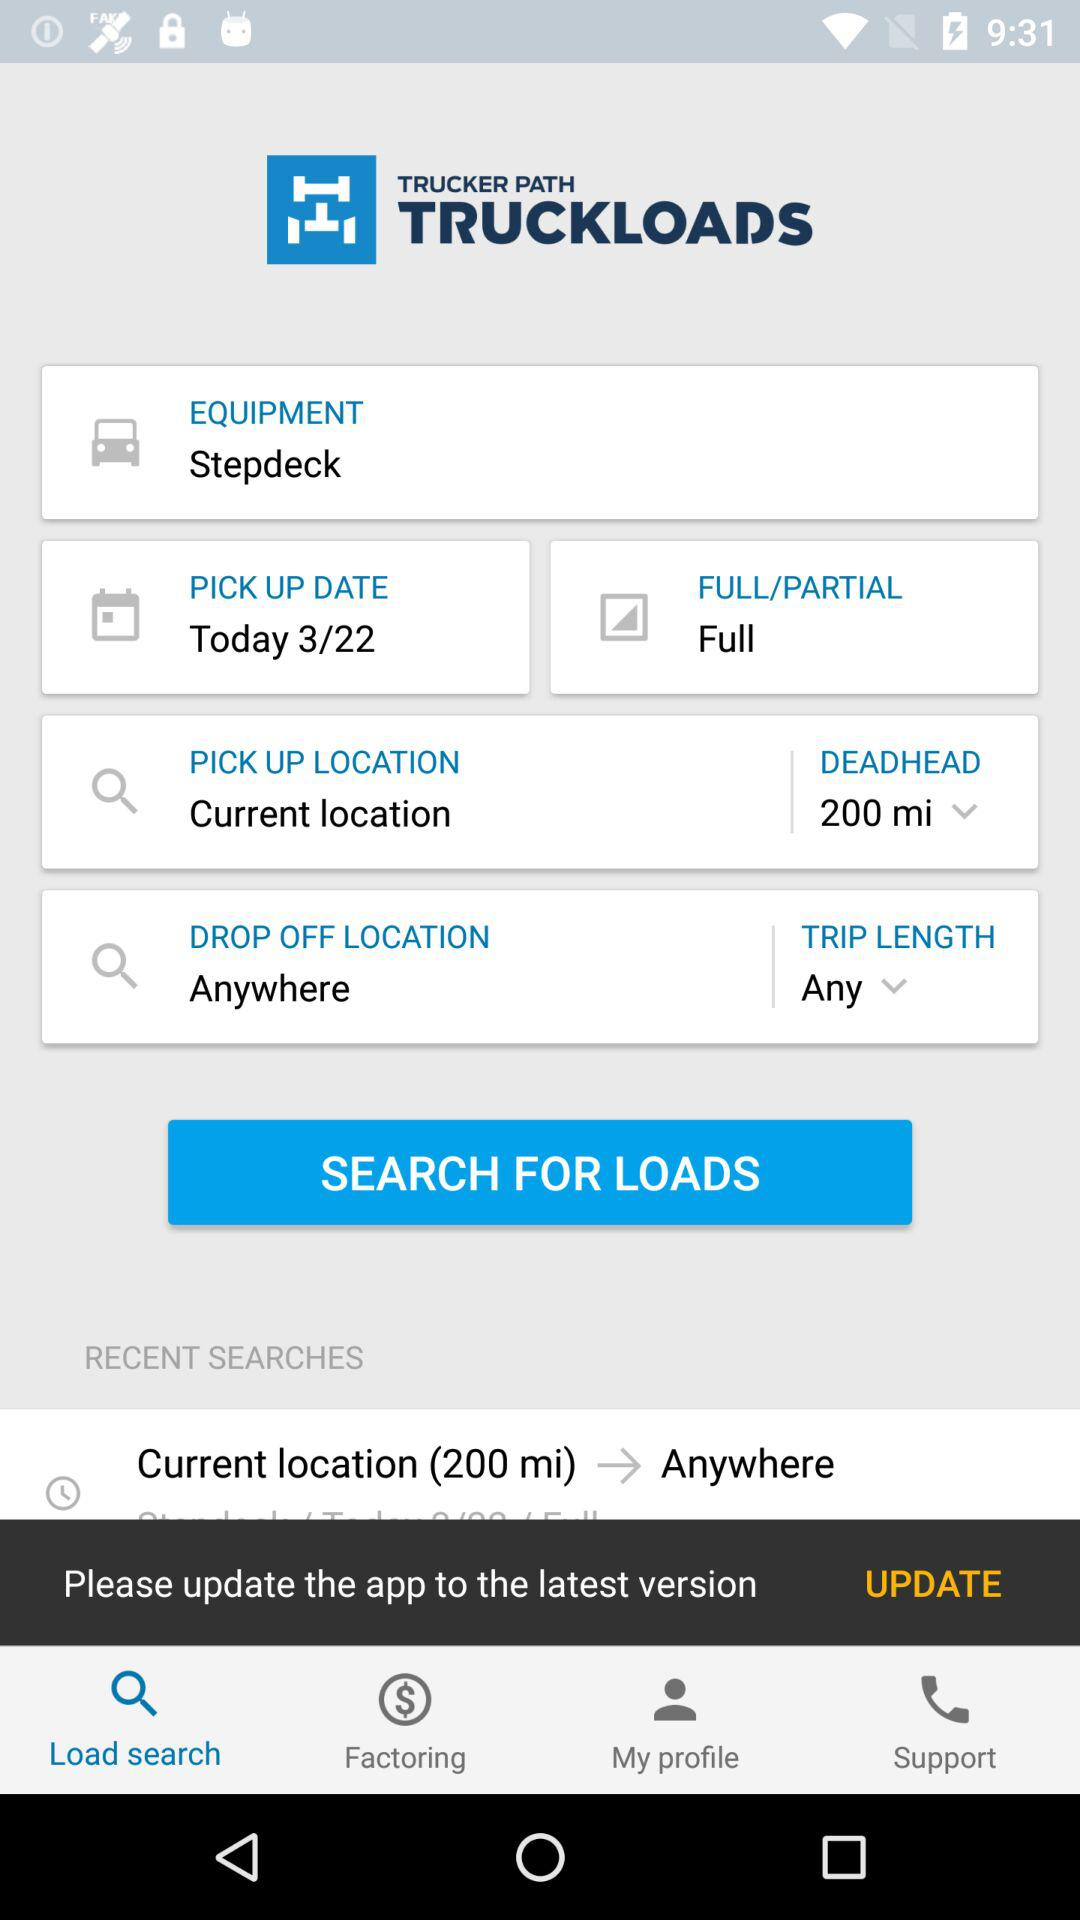How many miles is the deadhead distance?
Answer the question using a single word or phrase. 200 mi 